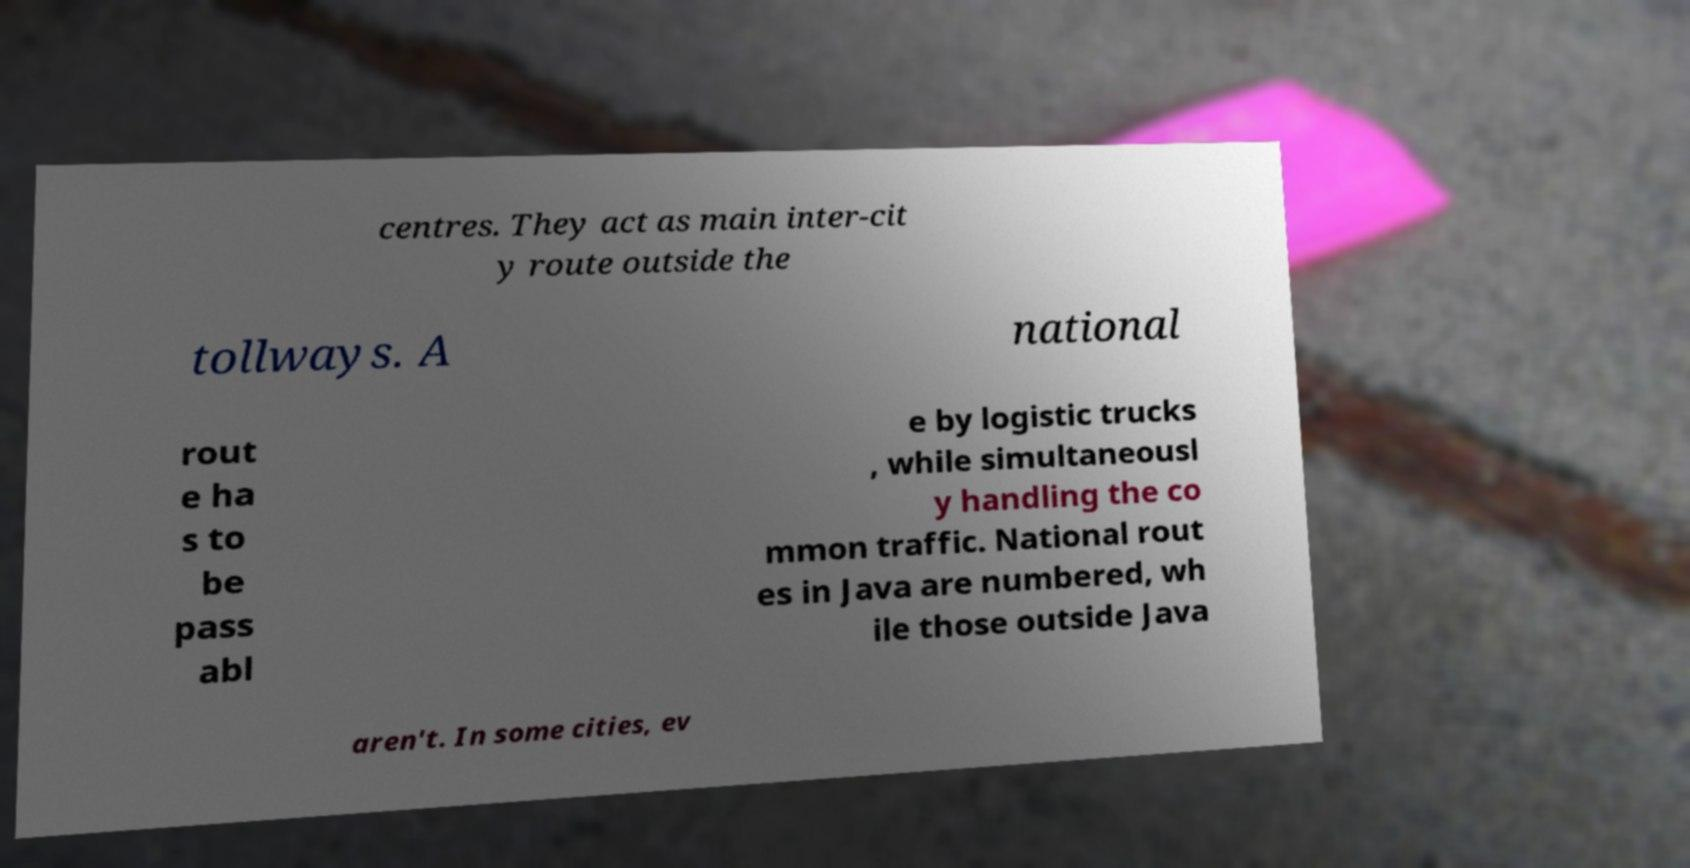Can you accurately transcribe the text from the provided image for me? centres. They act as main inter-cit y route outside the tollways. A national rout e ha s to be pass abl e by logistic trucks , while simultaneousl y handling the co mmon traffic. National rout es in Java are numbered, wh ile those outside Java aren't. In some cities, ev 